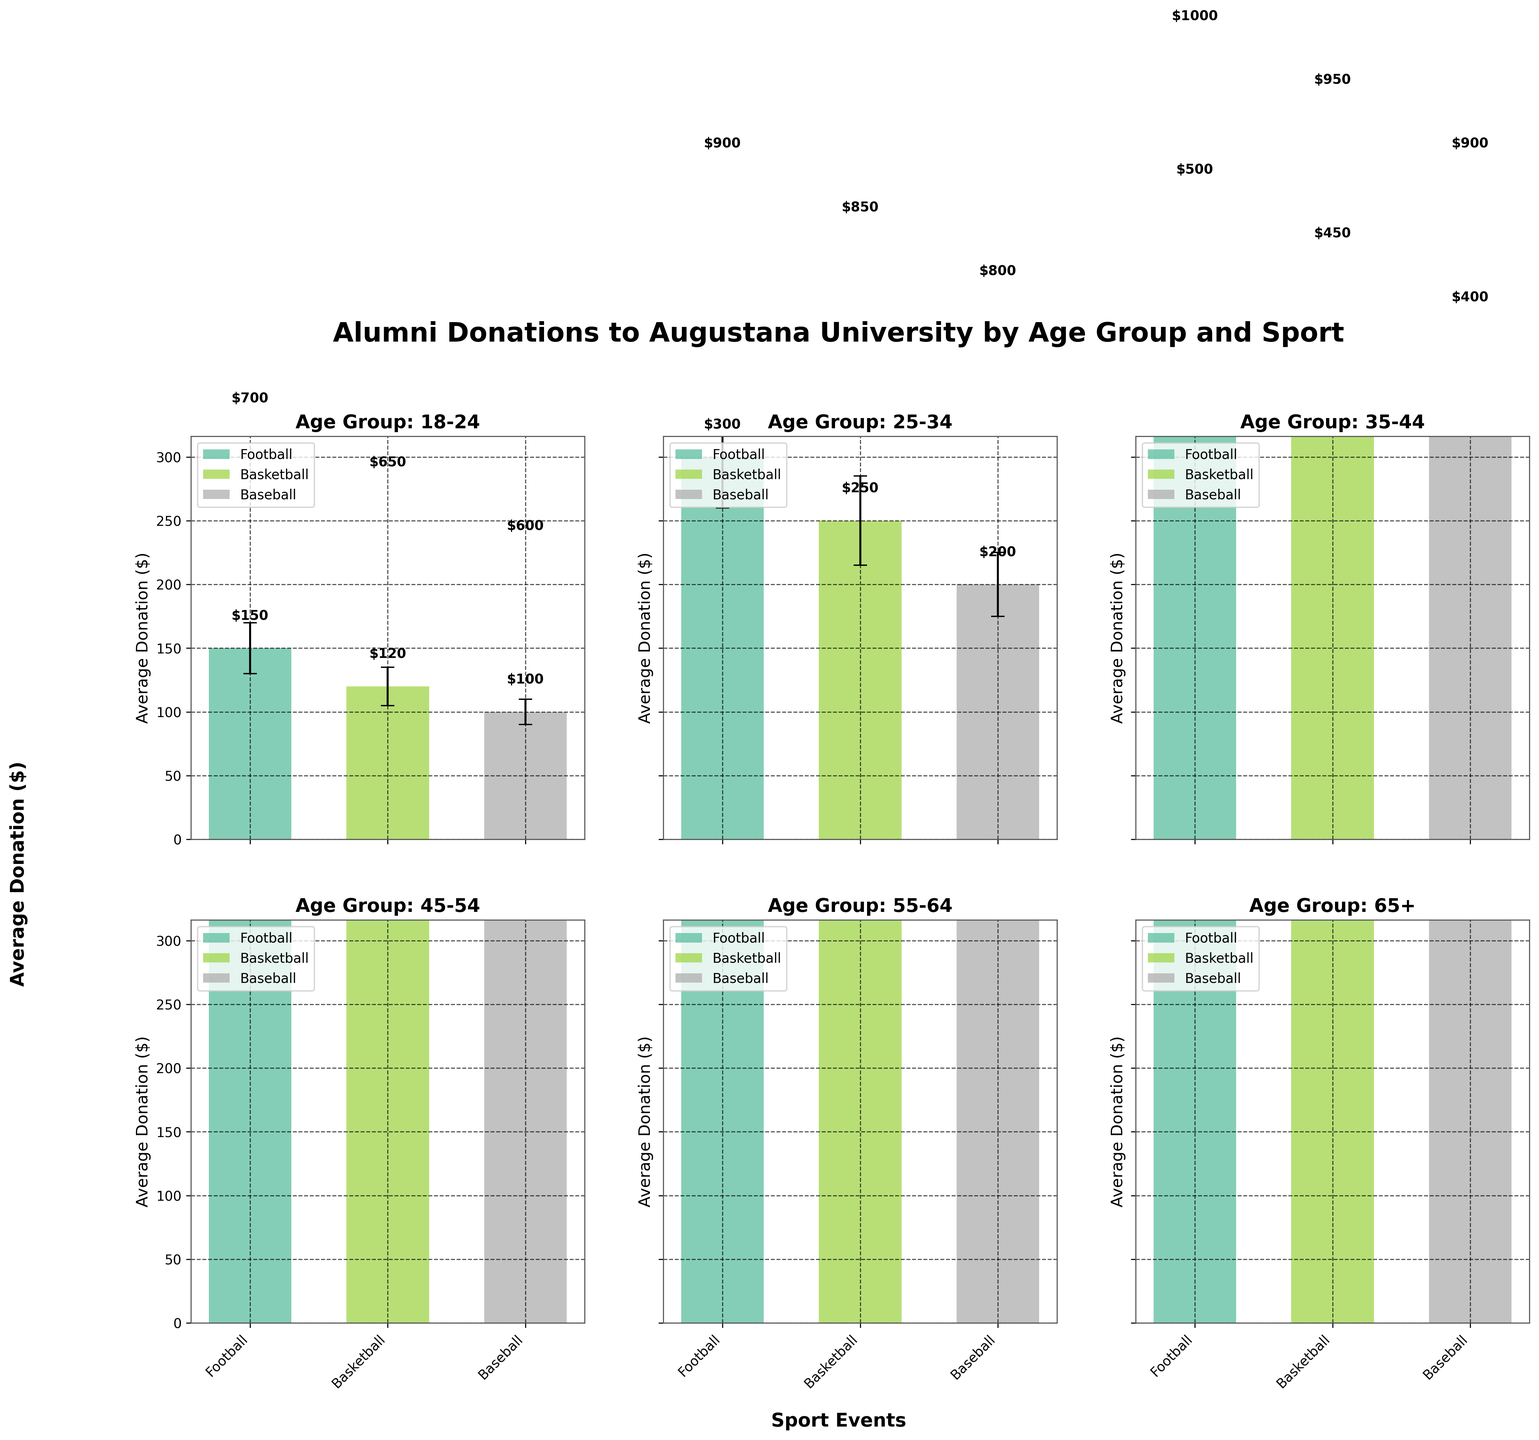Which age group has the highest average donation for football events? By observing the subplot for each age group, identify the one with the tallest bar in the football event category (usually colored consistently). The subplot for 65+ shows that their football average donation bar is the highest among all age groups.
Answer: 65+ What is the approximate range of average donations for all sports in the 25-34 age group? Look at the subplot for the 25-34 age group and note the heights of the donation bars across all sports. The range is approximately from $200 to $300.
Answer: $200 - $300 Which sport has the smallest donation variance in the 18-24 age group? Observe the error bars for each sport in the 18-24 subplot and identify the one with the shortest error bar. Baseball has the smallest donation variance for this age group.
Answer: Baseball How much more does the 45-54 age group donate on average for football compared to basketball? Find the average donation amounts for football and basketball in the 45-54 subplot. For football, it’s $700, and for basketball, it’s $650. The difference is $700 - $650 = $50.
Answer: $50 Which age group shows the most significant spread (variance) in donations for baseball? Inspect the error bars for baseball donations in each age group. The 65+ age group has the largest error bar, indicating the highest variance.
Answer: 65+ Compare the average donations for basketball fans between age groups 25-34 and 55-64. Which age group donates more, and by how much? Check the heights of the basketball donation bars for the 25-34 and 55-64 subplots. The average donation in the 25-34 age group is $250, and in the 55-64 age group, it’s $850. The difference is $850 - $250 = $600.
Answer: 55-64; $600 For the 35-44 age group, calculate the average donation considering all sports. Sum the average donations for all sports in the 35-44 age group: $500 (Football) + $450 (Basketball) + $400 (Baseball) = $1350. Divide by the number of sports (3): $1350 / 3 = $450.
Answer: $450 Between age groups 18-24 and 45-54, which group shows a more consistent donating pattern across different sports? Compare the lengths of the error bars for all sports within each age group. The 45-54 age group generally has longer error bars indicating higher variance, suggesting the 18-24 age group shows a more consistent pattern.
Answer: 18-24 